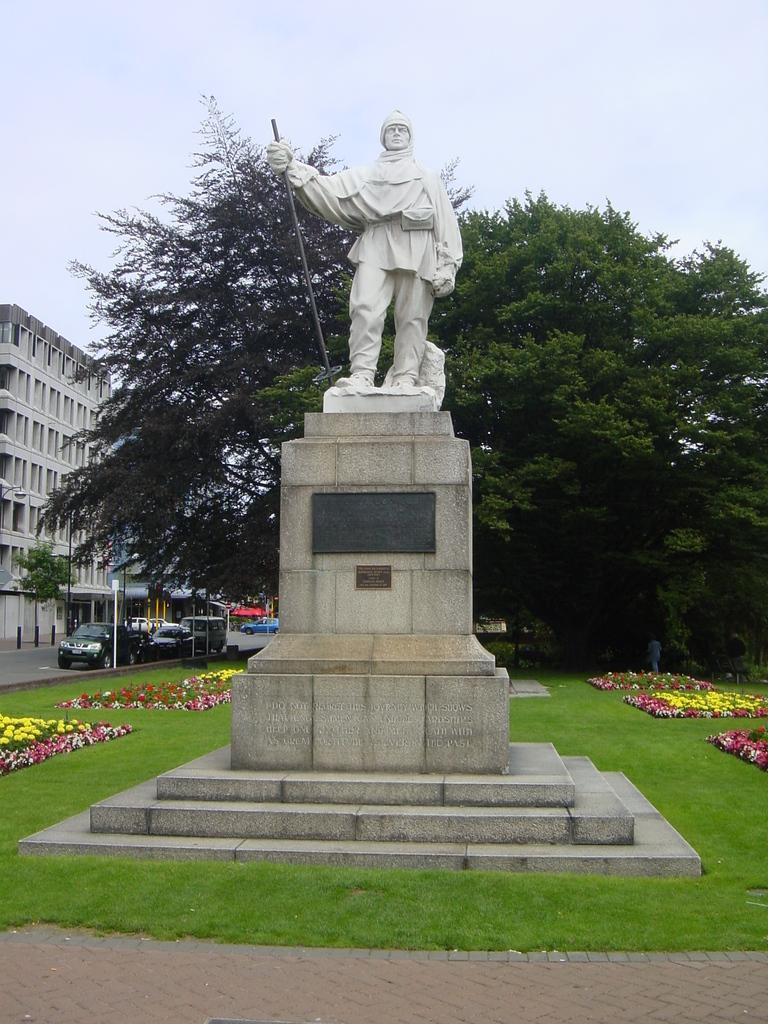How would you summarize this image in a sentence or two? In the image there is a statue of a person. On the ground there is grass and also there are flowers. In the background there are trees, cars and also there is a building. 